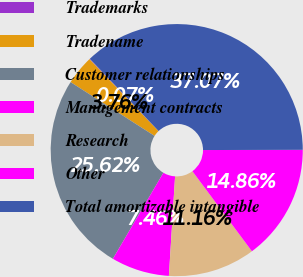<chart> <loc_0><loc_0><loc_500><loc_500><pie_chart><fcel>Trademarks<fcel>Tradename<fcel>Customer relationships<fcel>Management contracts<fcel>Research<fcel>Other<fcel>Total amortizable intangible<nl><fcel>0.07%<fcel>3.76%<fcel>25.61%<fcel>7.46%<fcel>11.16%<fcel>14.86%<fcel>37.06%<nl></chart> 